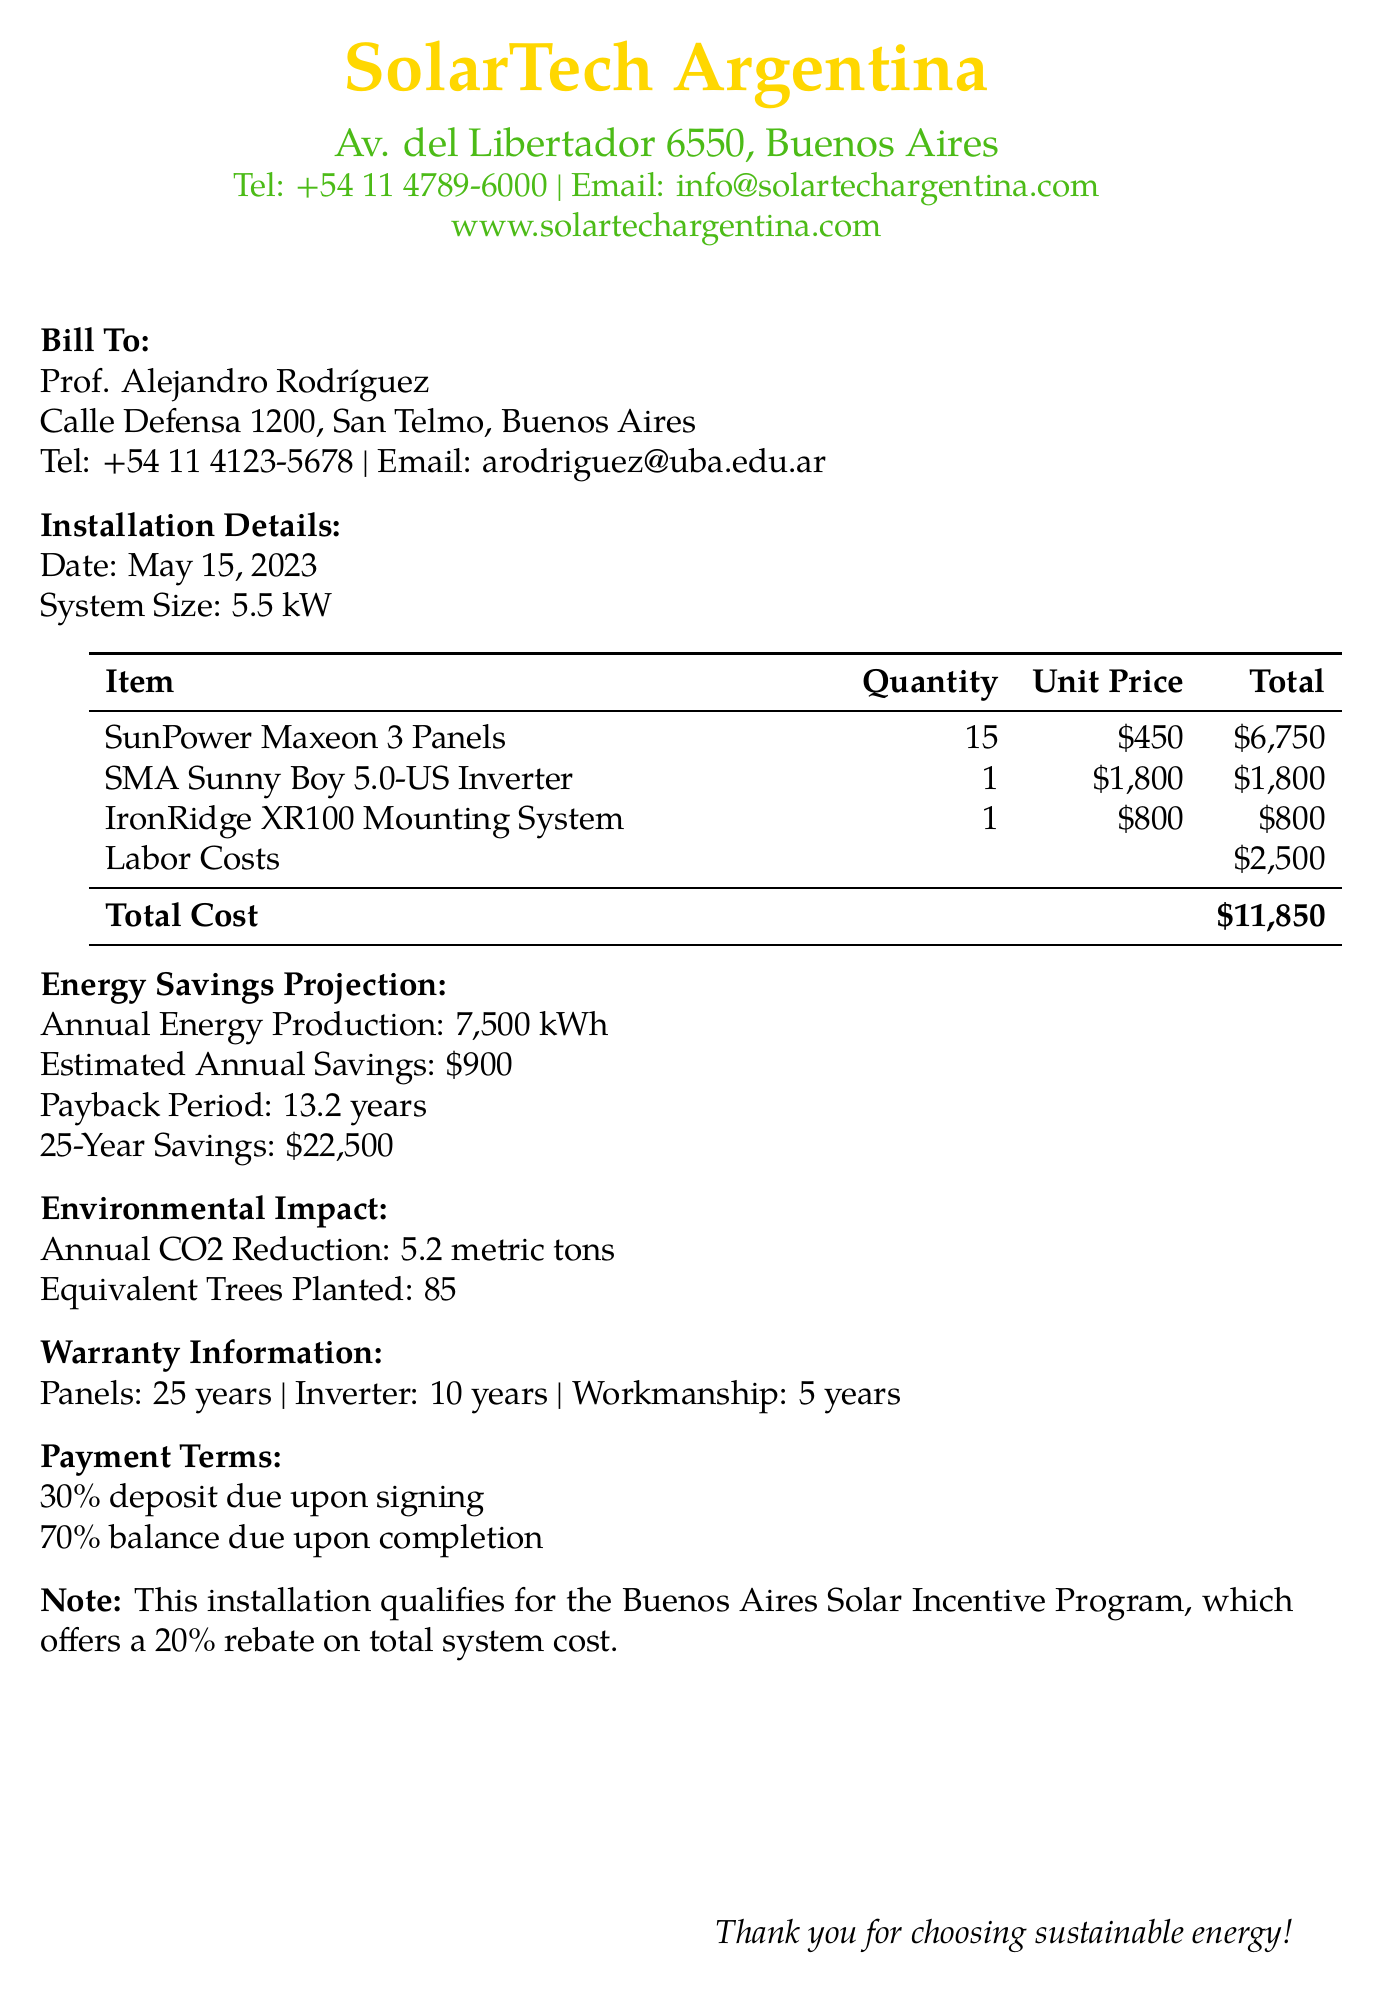what is the total cost of the installation? The total cost is indicated at the bottom of the cost table in the document, which totals $11,850.
Answer: $11,850 how many panels are included in the system? The quantity of SunPower Maxeon 3 Panels is listed in the table of equipment costs, showing 15 panels.
Answer: 15 what is the estimated annual savings? The estimated annual savings is mentioned under the Energy Savings Projection section, which calculates to $900.
Answer: $900 what is the payback period for the installation? The payback period is provided in the Energy Savings Projection section, calculated as 13.2 years.
Answer: 13.2 years how many metric tons of CO2 are reduced annually? The document specifies the annual CO2 reduction under the Environmental Impact section as 5.2 metric tons.
Answer: 5.2 metric tons what is the warranty period for the inverter? The warranty information section specifies that the inverter has a warranty period of 10 years.
Answer: 10 years how much rebate does the Buenos Aires Solar Incentive Program provide? The note mentions that the program offers a 20% rebate on the total system cost.
Answer: 20% what is the total annual energy production projected? The document states the annual energy production is 7,500 kWh in the Energy Savings Projection section.
Answer: 7,500 kWh what is the equivalent number of trees planted based on the CO2 reduction? The Environmental Impact section states that the equivalent number of trees planted is 85.
Answer: 85 